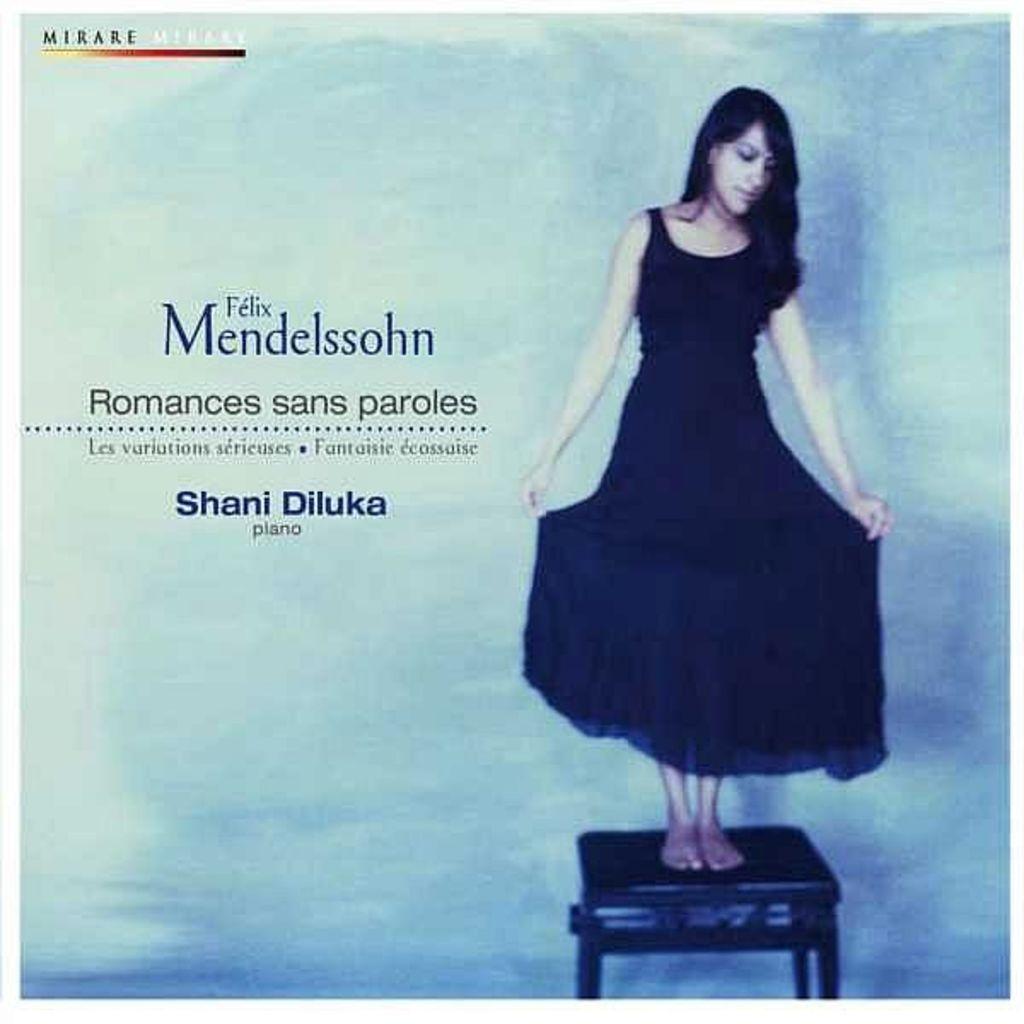Could you give a brief overview of what you see in this image? In this picture I can see a woman standing on the stool and I can see text on the left side and at the top left corner of the picture. 